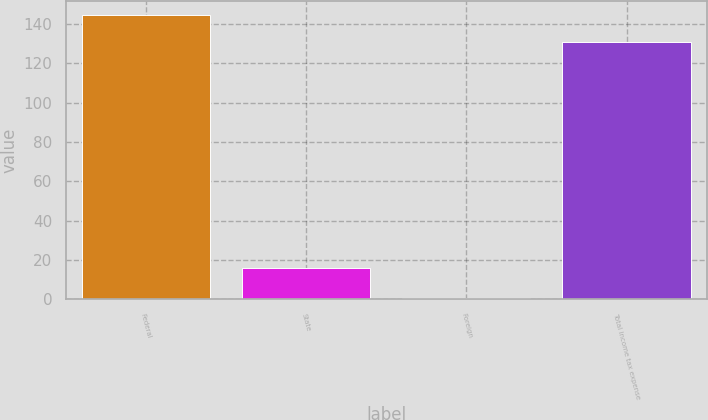Convert chart to OTSL. <chart><loc_0><loc_0><loc_500><loc_500><bar_chart><fcel>Federal<fcel>State<fcel>Foreign<fcel>Total income tax expense<nl><fcel>144.31<fcel>16.2<fcel>0.6<fcel>130.9<nl></chart> 